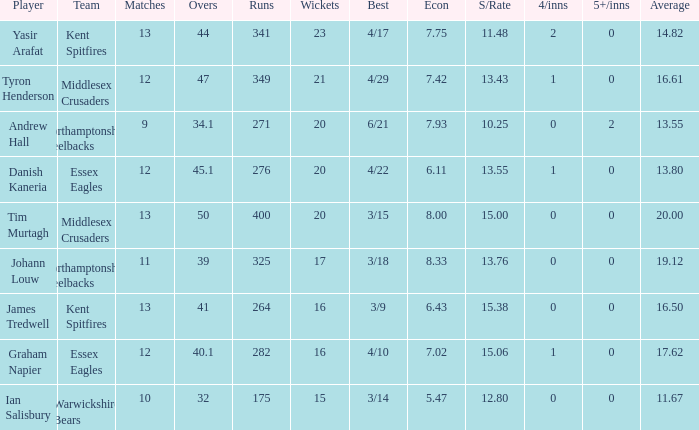Name the matches for wickets 17 11.0. 